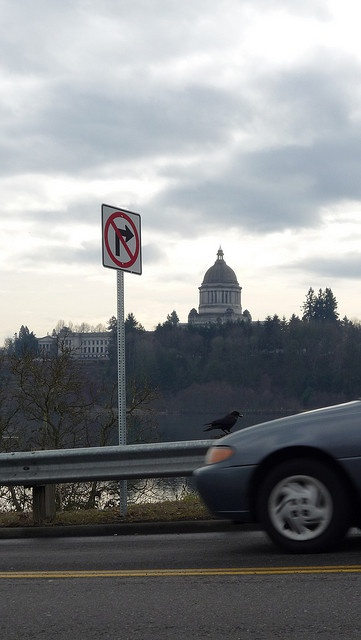Describe the objects in this image and their specific colors. I can see car in lightgray, black, and gray tones and bird in lightgray, black, and gray tones in this image. 